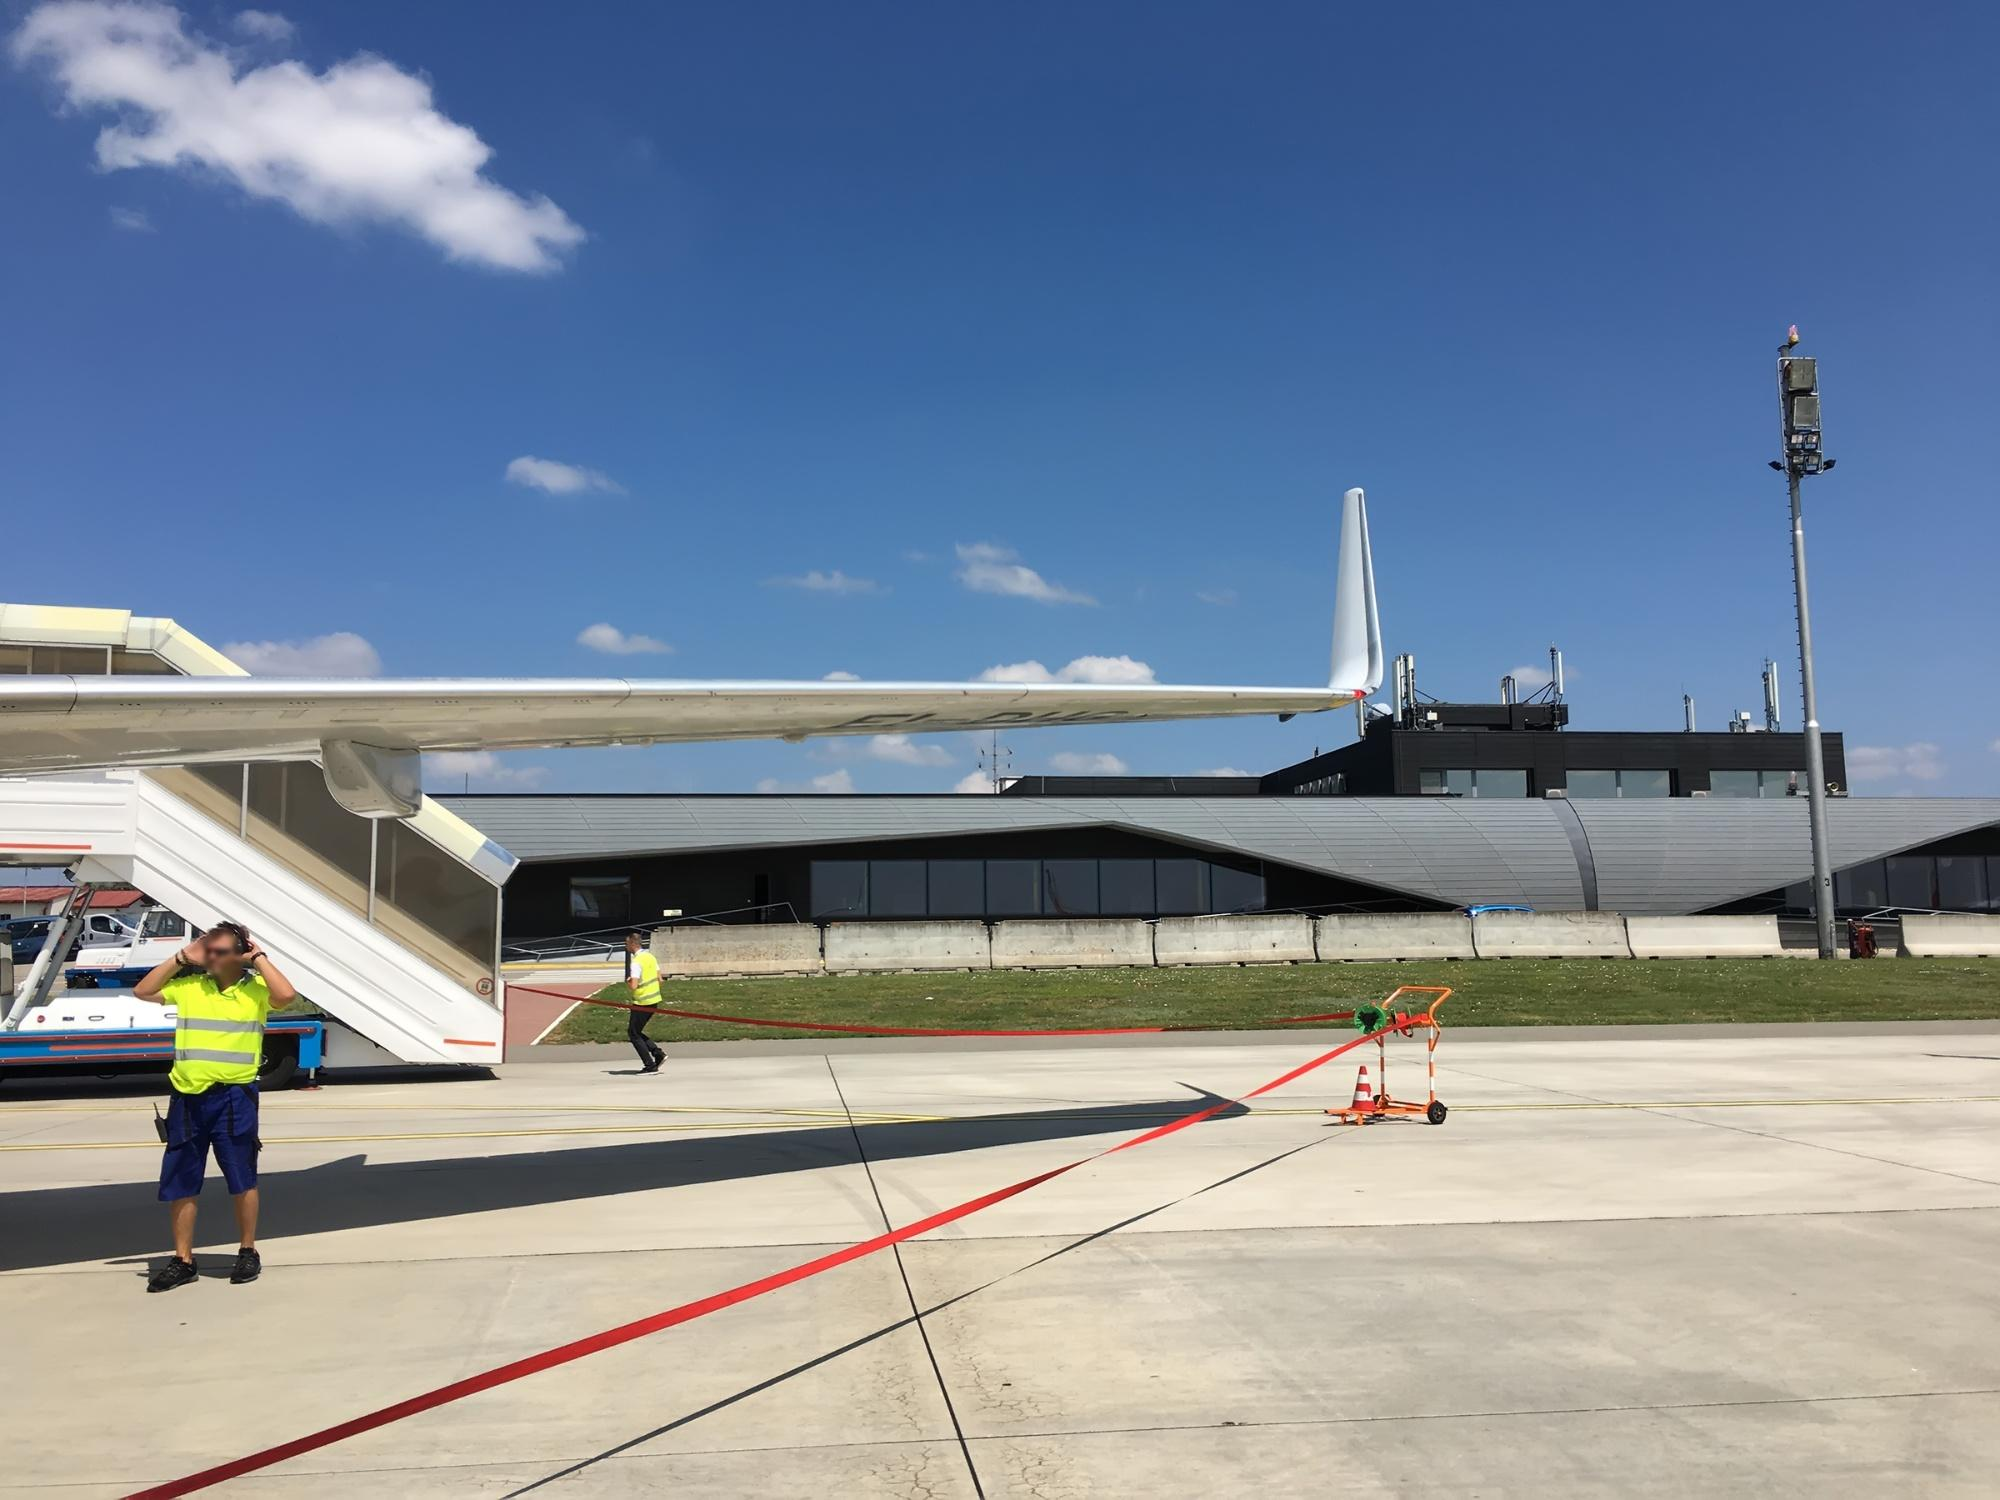What are the workers doing? The workers in the image appear to be involved in ground handling and safety procedures at the airport. One worker, positioned near the aircraft's mobile staircase, seems to be communicating through a headset, possibly coordinating with other ground crew or the aircraft's pilots. The other worker, further in the background, might be involved in towing or positioning equipment. Their bright yellow vests and diligent movements underscore the importance of safety and coordination in maintaining smooth airport operations, ensuring that the aircraft is ready for its next flight. Imagine a story where this airplane is a portal to another dimension. How would the scene unfold? As the sun rises over the airport, a seemingly ordinary day takes an extraordinary turn. The white airplane with a blue tail, a familiar sight on the tarmac, begins to hum with an unusual energy. The ground beneath it starts to shimmer, revealing an intricate pattern of ancient symbols glowing faintly. The two workers, initially engrossed in their routine tasks, pause and look up in awe as the airplane's body begins to radiate a soft, otherworldly light.

Inside the terminal, passengers suddenly find their boarding passes transformed, displaying cryptic maps and coordinates instead of seat numbers. As they board the aircraft, they're filled with a sense of adventure and curiosity, unaware that this flight will take them beyond the Earth's skies.

As the plane takes off, it ascends higher than any commercial aircraft ever has, breaking through a layer of bright clouds that form a gateway to another dimension. On the other side, the passengers and crew find themselves in a surreal landscape filled with floating islands, vibrant flora, and skies painted in hues unknown to Earth. This dimension, teeming with life and mysteries, offers endless exploration opportunities, revealing secrets about the universe and history long forgotten by humankind.

Guided by the ancient symbols, the airplane navigates this new world with ease, its passengers embarking on adventures they had never imagined. This extraordinary flight becomes a legend, a story passed down through generations, blending the boundaries between reality and myth. What do you think the weather will be like tomorrow based on this image? Based on the image, which shows a clear, blue sky with a few scattered clouds and ample sunlight, it is likely that the weather will remain good tomorrow as well. The visibility seems excellent, and there are no signs of an impending storm or severe weather conditions. It suggests that tomorrow will also be bright and sunny, making it an ideal day for flights and other outdoor activities. Of course, weather predictions are not always accurate, and it’s always good to check an official weather report. 